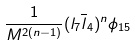Convert formula to latex. <formula><loc_0><loc_0><loc_500><loc_500>\frac { 1 } { M ^ { 2 ( n - 1 ) } } ( l _ { 7 } { \overline { l } } _ { 4 } ) ^ { n } \phi _ { 1 5 }</formula> 